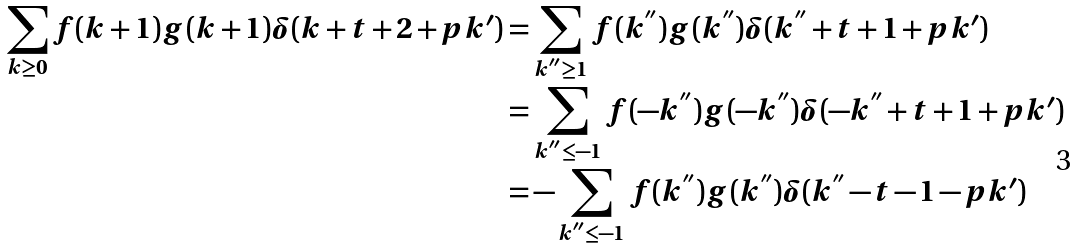<formula> <loc_0><loc_0><loc_500><loc_500>\sum _ { k \geq 0 } f ( k + 1 ) g ( k + 1 ) \delta ( k + t + 2 + p k ^ { \prime } ) & = \sum _ { k ^ { ^ { \prime \prime } } \geq 1 } f ( k ^ { ^ { \prime \prime } } ) g ( k ^ { ^ { \prime \prime } } ) \delta ( k ^ { ^ { \prime \prime } } + t + 1 + p k ^ { \prime } ) \\ & = \sum _ { k ^ { ^ { \prime \prime } } \leq - 1 } f ( - k ^ { ^ { \prime \prime } } ) g ( - k ^ { ^ { \prime \prime } } ) \delta ( - k ^ { ^ { \prime \prime } } + t + 1 + p k ^ { \prime } ) \\ & = - \sum _ { k ^ { ^ { \prime \prime } } \leq - 1 } f ( k ^ { ^ { \prime \prime } } ) g ( k ^ { ^ { \prime \prime } } ) \delta ( k ^ { ^ { \prime \prime } } - t - 1 - p k ^ { \prime } )</formula> 